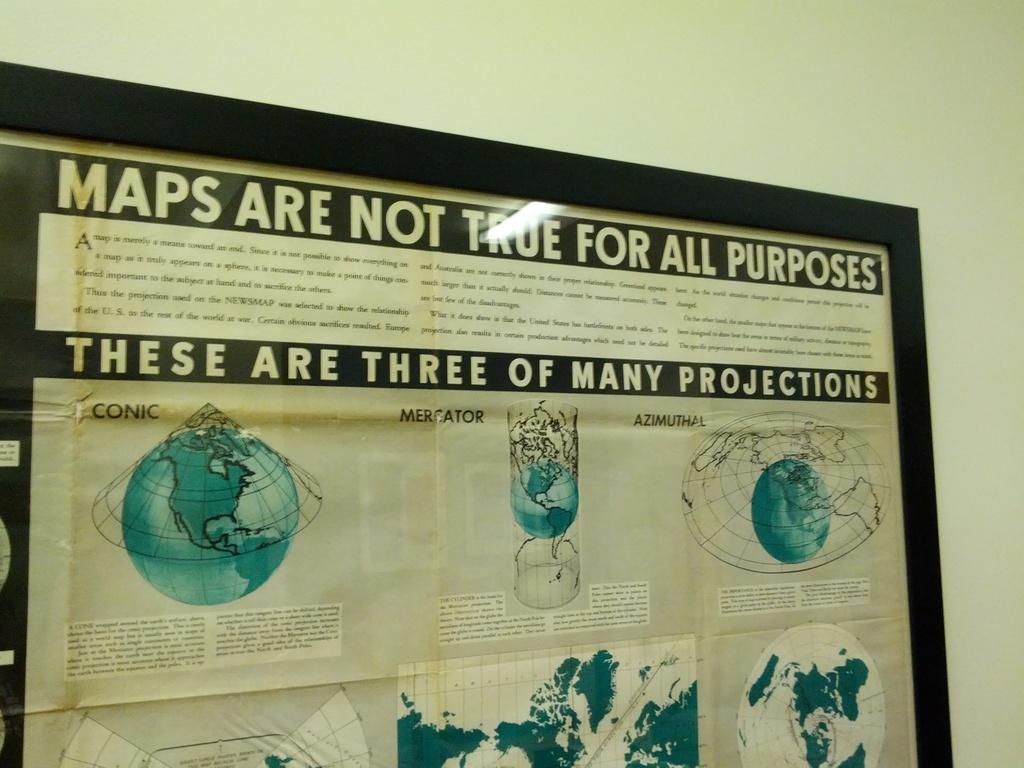What isn't true for all purposes?
Keep it short and to the point. Maps. How many projections does the sign display?
Your response must be concise. Three. 